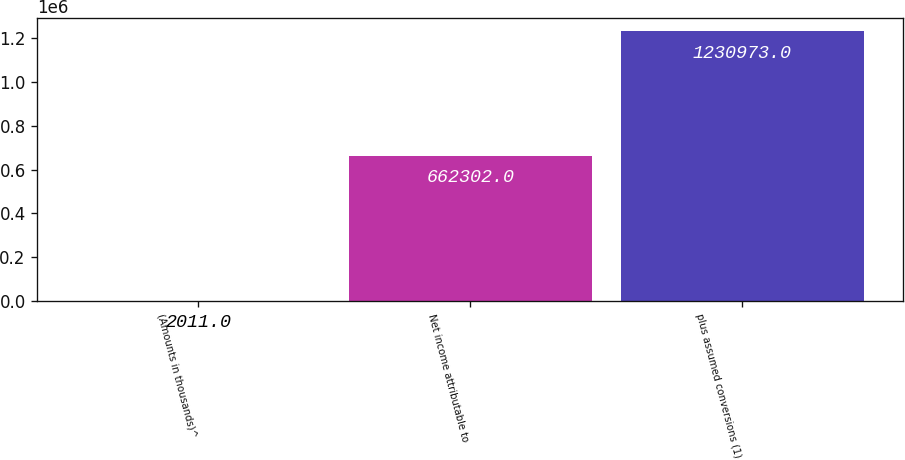Convert chart. <chart><loc_0><loc_0><loc_500><loc_500><bar_chart><fcel>(Amounts in thousands)^<fcel>Net income attributable to<fcel>plus assumed conversions (1)<nl><fcel>2011<fcel>662302<fcel>1.23097e+06<nl></chart> 